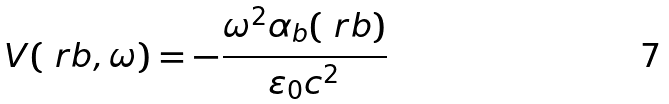<formula> <loc_0><loc_0><loc_500><loc_500>V ( \ r b , \omega ) = - \frac { \omega ^ { 2 } \alpha _ { b } ( \ r b ) } { \varepsilon _ { 0 } c ^ { 2 } }</formula> 